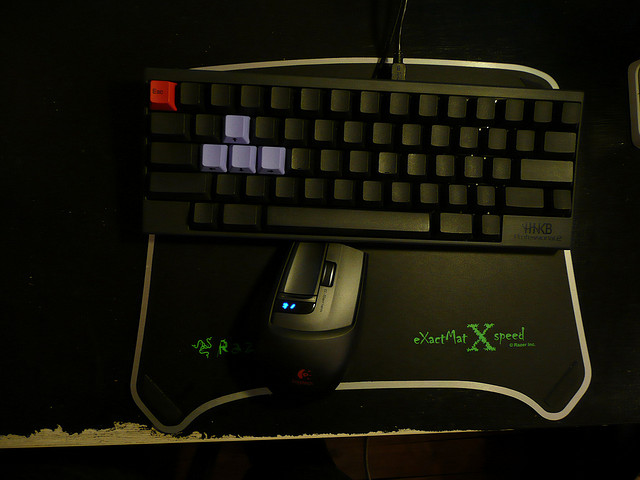Extract all visible text content from this image. eXact Mat X speed R HIKB 